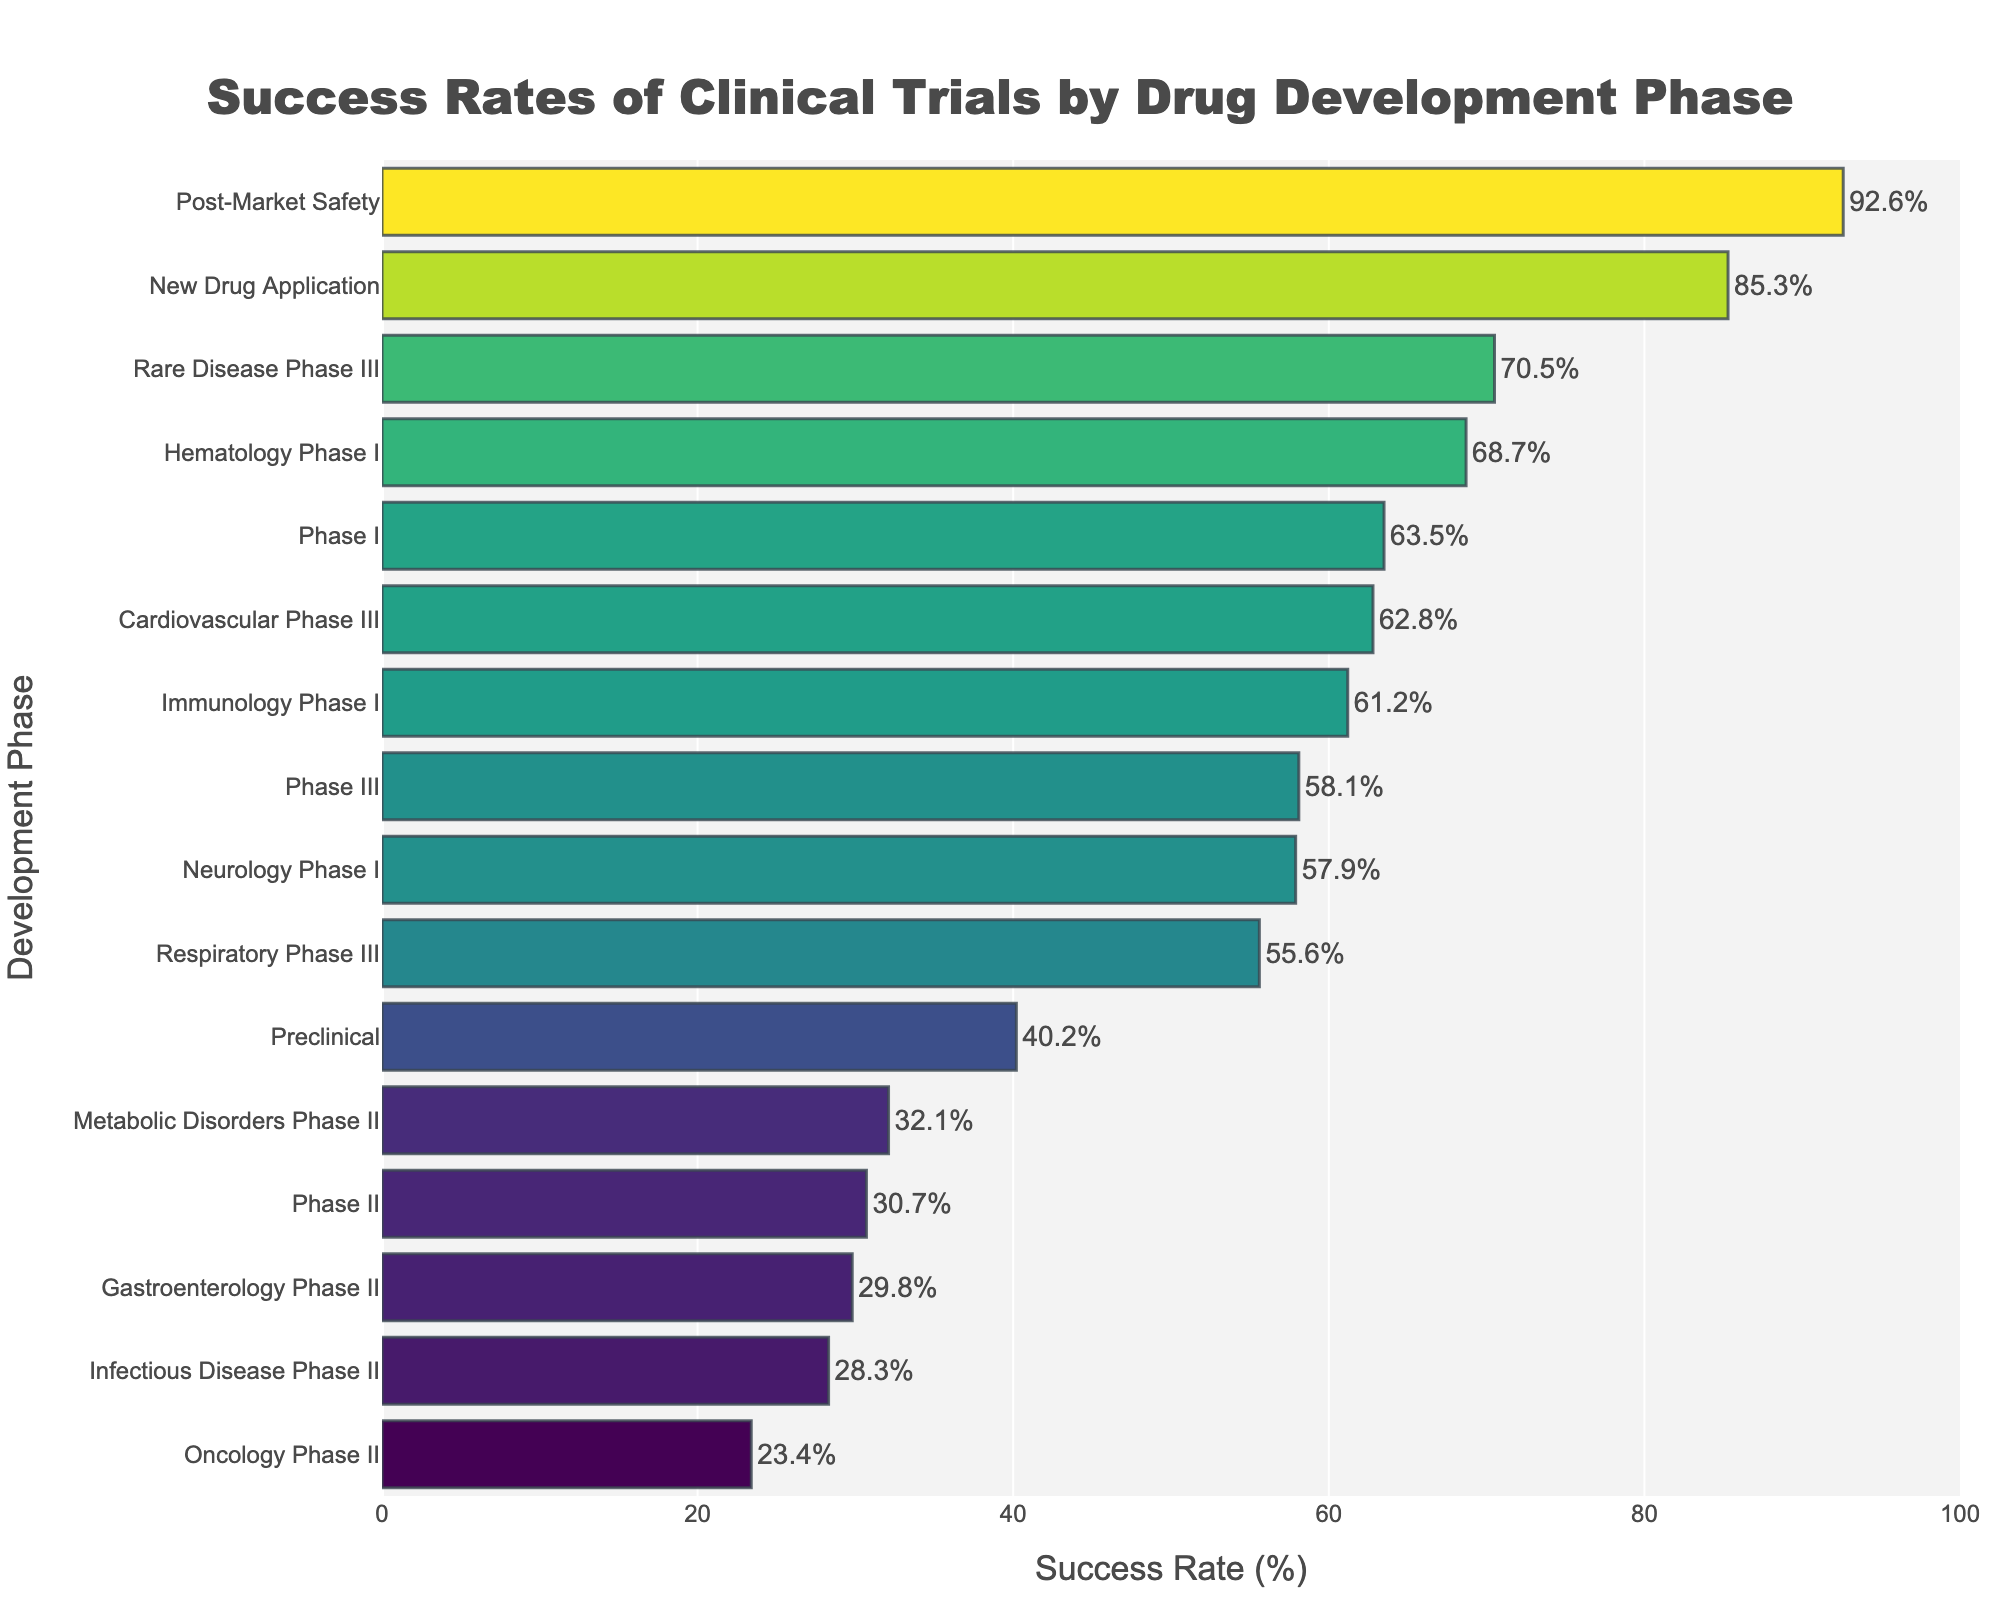What is the success rate of the Preclinical phase? Locate the "Preclinical" phase on the y-axis and check the length of the corresponding bar on the x-axis, which indicates the success rate.
Answer: 40.2% Which phase has the highest success rate? Look for the longest horizontal bar as it represents the highest value on the x-axis. The "Post-Market Safety" phase has the longest bar.
Answer: Post-Market Safety What is the average success rate of Phase III, Cardiovascular Phase III, Rare Disease Phase III, and Respiratory Phase III? Sum the success rates of these phases (58.1 + 62.8 + 70.5 + 55.6) and divide by the number of phases (4). Calculation: (58.1 + 62.8 + 70.5 + 55.6) = 247. Divide by 4 gives 61.75.
Answer: 61.75% Which phase has a lower success rate, Oncology Phase II or Infectious Disease Phase II? Compare the bars for "Oncology Phase II" (23.4%) and "Infectious Disease Phase II" (28.3%). The shorter bar belongs to Oncology Phase II.
Answer: Oncology Phase II By how much does the success rate for the New Drug Application phase exceed that of the Preclinical phase? Subtract the success rate of the Preclinical phase (40.2%) from that of the New Drug Application phase (85.3%). Calculation: 85.3 - 40.2 = 45.1.
Answer: 45.1% Which phase has the shortest bar? Identify the shortest horizontal bar, which represents the lowest success rate. The "Oncology Phase II" phase has the shortest bar.
Answer: Oncology Phase II Is the success rate for Immunology Phase I greater or less than Hematology Phase I? Compare the bars for "Immunology Phase I" (61.2%) and "Hematology Phase I" (68.7%). Hematology Phase I has a longer bar, indicating a higher success rate.
Answer: Less What is the difference in success rates between Gastroenterology Phase II and Metabolic Disorders Phase II? Subtract the success rate of "Metabolic Disorders Phase II" (32.1%) from "Gastroenterology Phase II" (29.8%). Calculation: 32.1 - 29.8 = 2.3.
Answer: 2.3% Are there any phases with a success rate below 30%? If yes, name them. Identify phases with bars below the 30% mark. "Oncology Phase II," "Infectious Disease Phase II," and "Gastroenterology Phase II" have success rates below 30%.
Answer: Oncology Phase II, Infectious Disease Phase II, Gastroenterology Phase II How many phases have a success rate above 60%? Count the bars that extend beyond the 60% mark on the x-axis: "Phase I," "New Drug Application," "Post-Market Safety," "Cardiovascular Phase III," "Rare Disease Phase III," "Immunology Phase I," and "Hematology Phase I." There are 7 such phases.
Answer: 7 